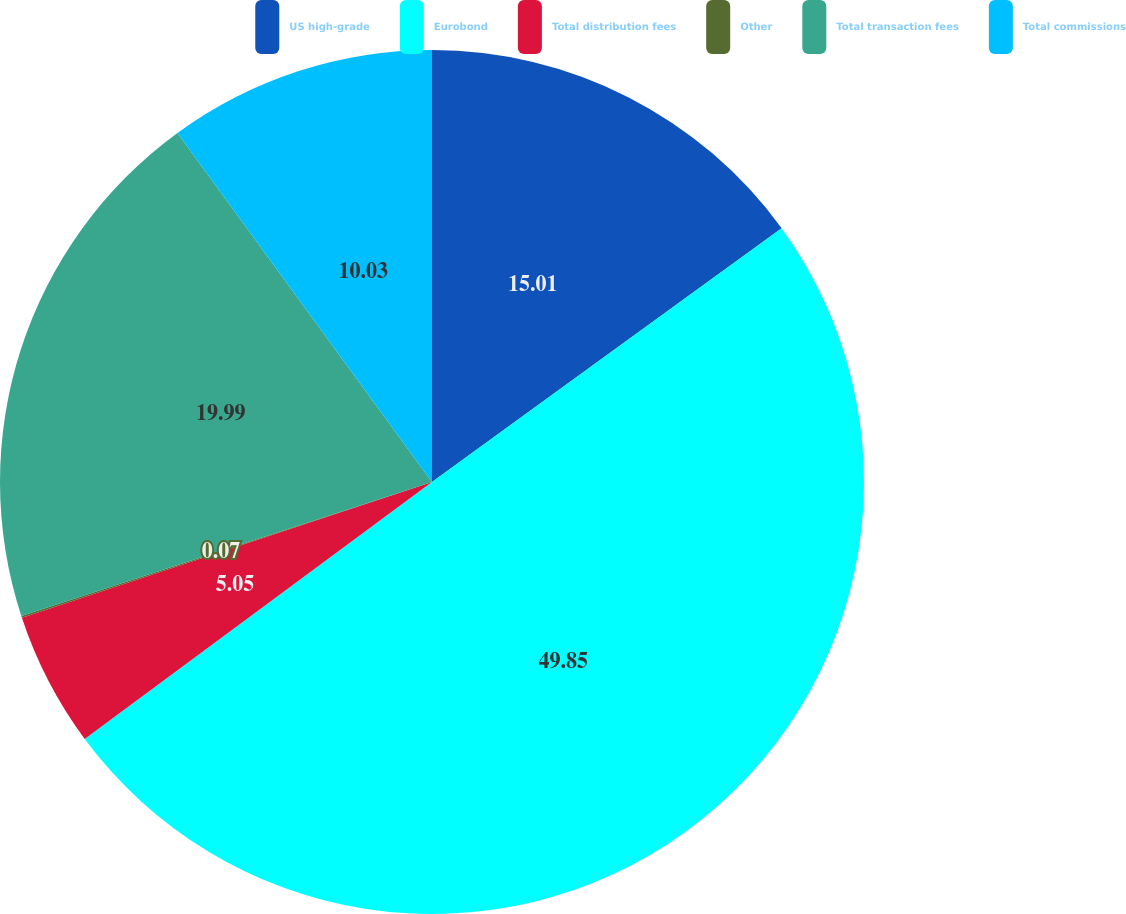<chart> <loc_0><loc_0><loc_500><loc_500><pie_chart><fcel>US high-grade<fcel>Eurobond<fcel>Total distribution fees<fcel>Other<fcel>Total transaction fees<fcel>Total commissions<nl><fcel>15.01%<fcel>49.86%<fcel>5.05%<fcel>0.07%<fcel>19.99%<fcel>10.03%<nl></chart> 